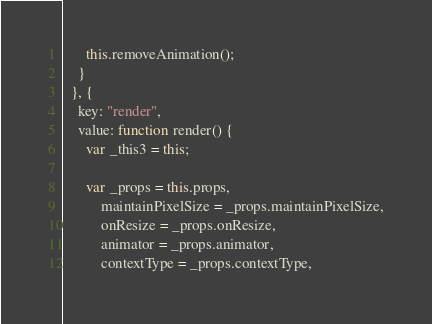Convert code to text. <code><loc_0><loc_0><loc_500><loc_500><_JavaScript_>      this.removeAnimation();
    }
  }, {
    key: "render",
    value: function render() {
      var _this3 = this;

      var _props = this.props,
          maintainPixelSize = _props.maintainPixelSize,
          onResize = _props.onResize,
          animator = _props.animator,
          contextType = _props.contextType,</code> 